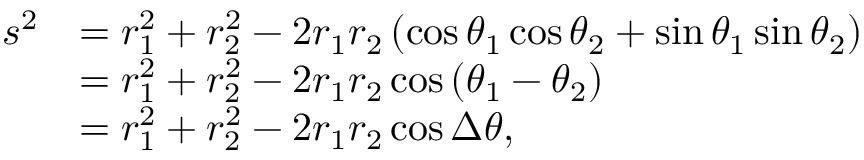Convert formula to latex. <formula><loc_0><loc_0><loc_500><loc_500>{ \begin{array} { r l } { s ^ { 2 } } & { = r _ { 1 } ^ { 2 } + r _ { 2 } ^ { 2 } - 2 r _ { 1 } r _ { 2 } \left ( \cos \theta _ { 1 } \cos \theta _ { 2 } + \sin \theta _ { 1 } \sin \theta _ { 2 } \right ) } \\ & { = r _ { 1 } ^ { 2 } + r _ { 2 } ^ { 2 } - 2 r _ { 1 } r _ { 2 } \cos \left ( \theta _ { 1 } - \theta _ { 2 } \right ) } \\ & { = r _ { 1 } ^ { 2 } + r _ { 2 } ^ { 2 } - 2 r _ { 1 } r _ { 2 } \cos \Delta \theta , } \end{array} }</formula> 